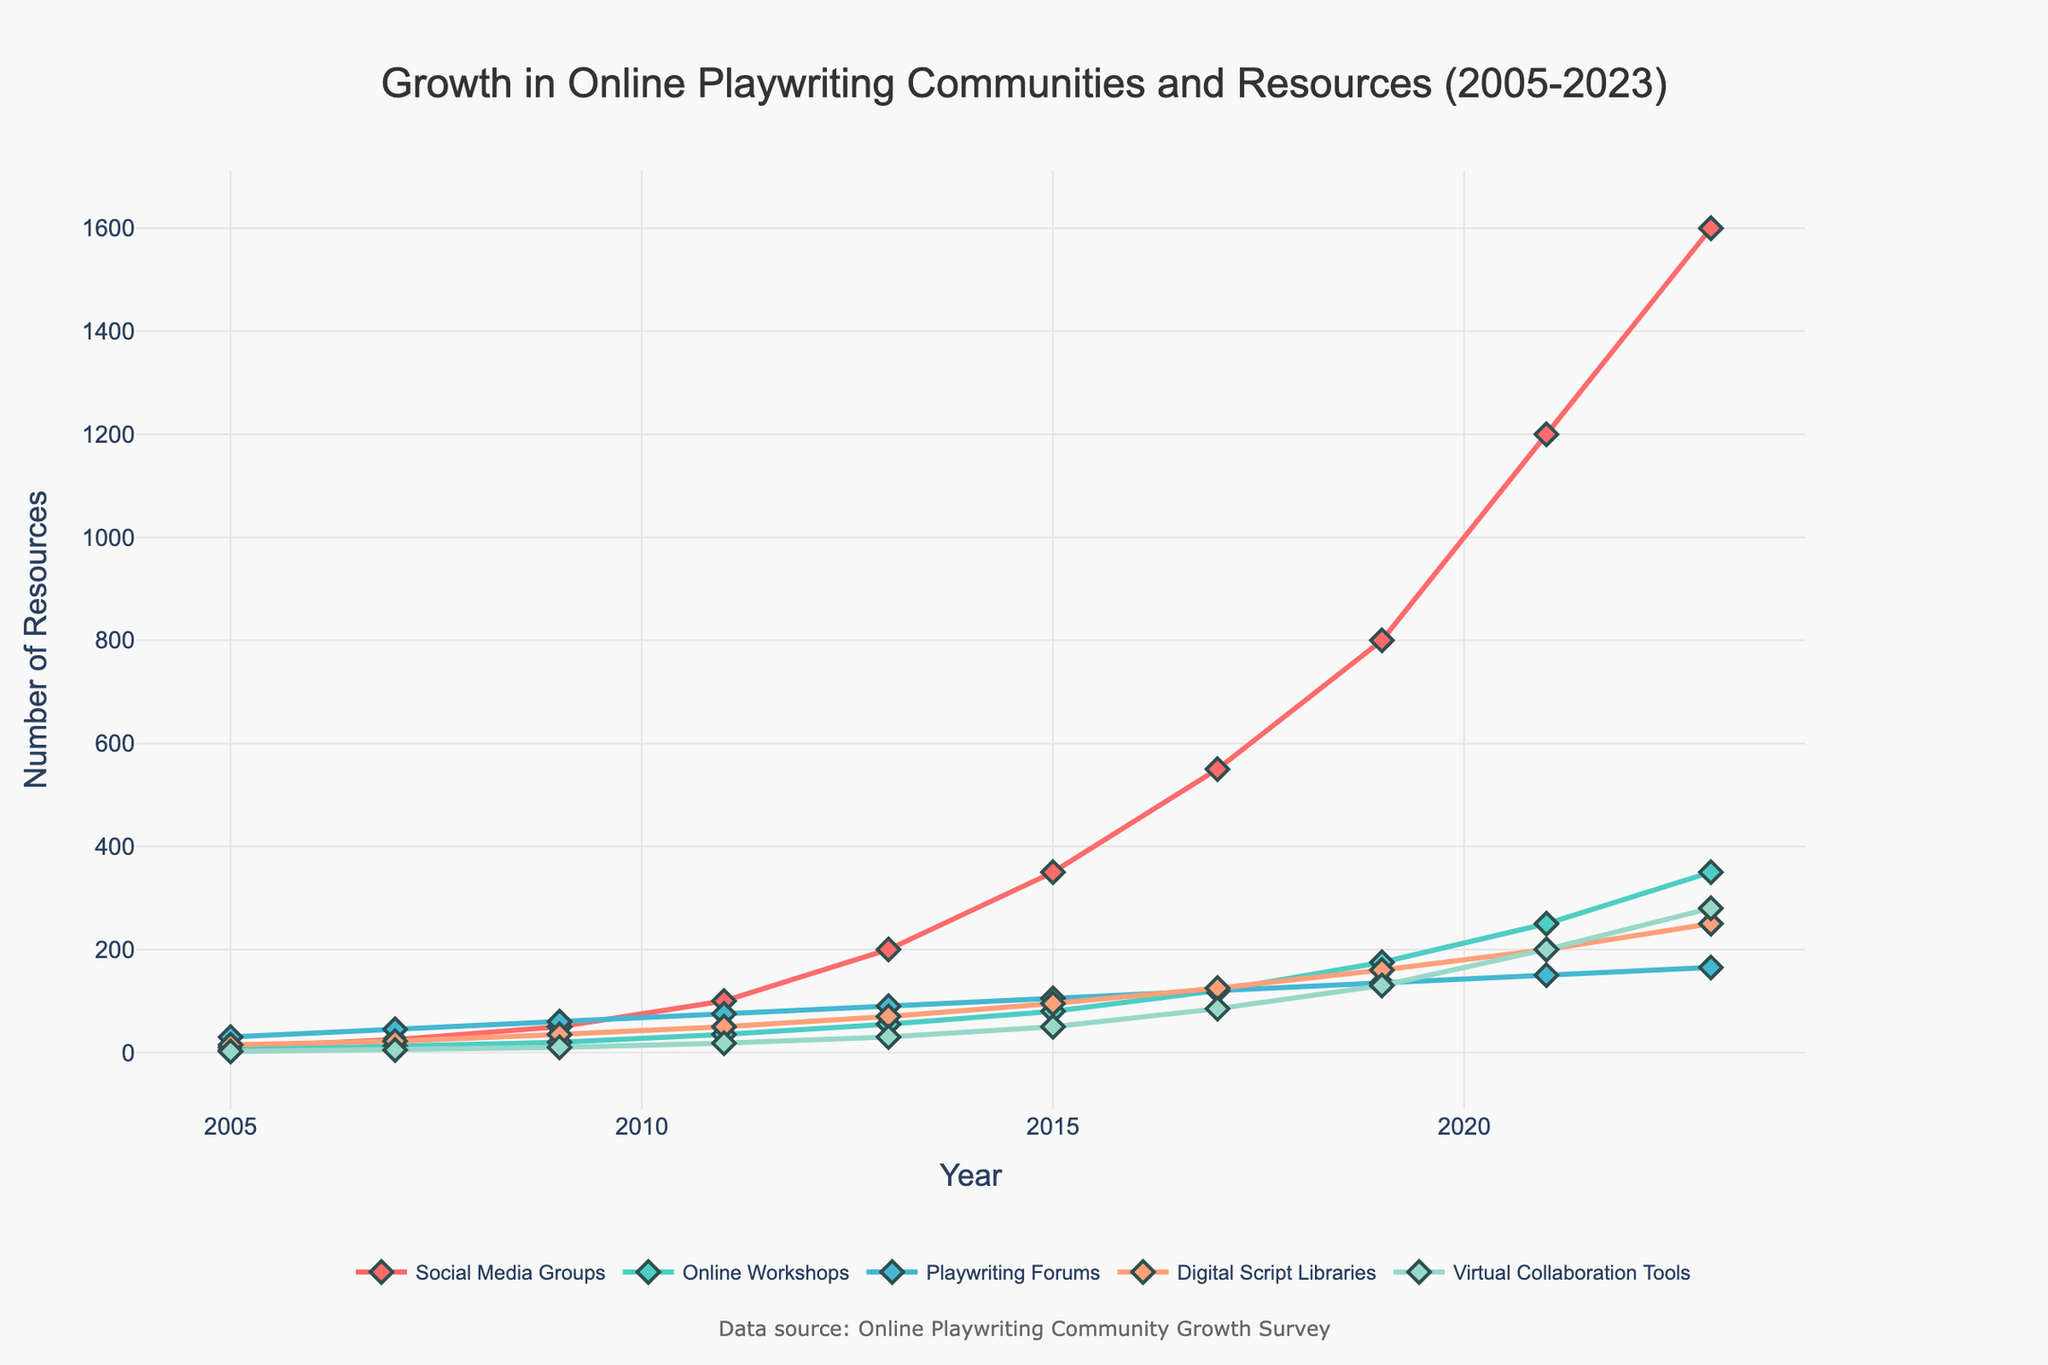How did the number of Social Media Groups change from 2009 to 2013? Compare the value in 2009 (50) to the value in 2013 (200). The number increased by 150.
Answer: Increased by 150 Which platform showed the most growth between 2019 and 2023? Check the values for all platforms in 2019 and 2023, then calculate the growth (2023 value - 2019 value). Social Media Groups had the highest growth (1600 - 800 = 800).
Answer: Social Media Groups By how much did the number of Online Workshops increase in the periods 2009-2011 and 2011-2013? Calculate the differences for each period: from 2009 to 2011 (35 - 20 = 15) and from 2011 to 2013 (55 - 35 = 20). The total increase is 15 + 20 = 35.
Answer: 35 What year did Virtual Collaboration Tools see the first significant jump, and by how much? Identify the first significant jump by visual inspection. The tools jumped notably from 2011 (18) to 2013 (30), a difference of 12.
Answer: 2013, by 12 Compare the growth trends of Digital Script Libraries and Social Media Groups from 2017 to 2023. Inspect the values in the given years for each category: Digital Script Libraries grew from 125 to 250, an increase of 125, while Social Media Groups grew from 550 to 1600, an increase of 1050.
Answer: Social Media Groups grew the most How many platforms had a consistent increase in every recorded period? Analyze each platform's values from one period to the next. All platforms feature a consistent increase except Playwriting Forums, which show a dip between 2021 (150) and 2023 (165).
Answer: 4 out of 5 Which platform had the smallest growth rate from 2005 to 2023? Compute the growth rates (2023 value - 2005 value) for each category. Virtual Collaboration Tools grew the least (280 - 2 = 278).
Answer: Virtual Collaboration Tools What is the overall trend for Playwriting Forums, and how did it change between 2021 and 2023? Identify the overall trend, then look specifically at the change from 2021 (150) to 2023 (165). Playwriting Forums have a generally increasing trend, with a small increase of 15 in the final period.
Answer: Generally increasing, +15 Which year did the number of Digital Script Libraries reach the same level as Social Media Groups in 2009? Compare the values to find when Digital Script Libraries matched Social Media Groups' value in 2009 (50). Digital Script Libraries reached this value between 2011 (50) and 2013 (70).
Answer: 2011 